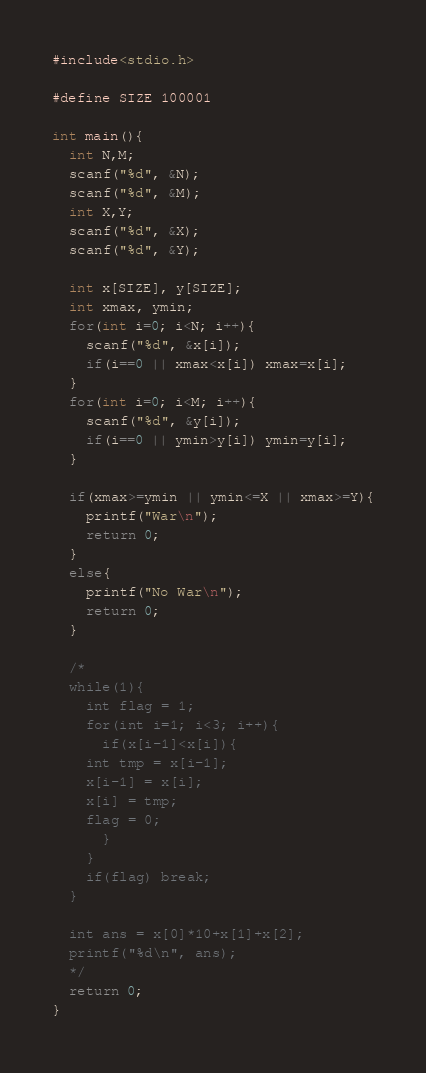Convert code to text. <code><loc_0><loc_0><loc_500><loc_500><_C_>#include<stdio.h>

#define SIZE 100001

int main(){
  int N,M;
  scanf("%d", &N);
  scanf("%d", &M);
  int X,Y;
  scanf("%d", &X);
  scanf("%d", &Y);

  int x[SIZE], y[SIZE];
  int xmax, ymin;
  for(int i=0; i<N; i++){
    scanf("%d", &x[i]);
    if(i==0 || xmax<x[i]) xmax=x[i];
  }
  for(int i=0; i<M; i++){
    scanf("%d", &y[i]);   
    if(i==0 || ymin>y[i]) ymin=y[i];
  }

  if(xmax>=ymin || ymin<=X || xmax>=Y){
    printf("War\n");
    return 0;
  }
  else{
    printf("No War\n");
    return 0;
  }

  /*
  while(1){
    int flag = 1;
    for(int i=1; i<3; i++){
      if(x[i-1]<x[i]){
	int tmp = x[i-1];
	x[i-1] = x[i];
	x[i] = tmp;
	flag = 0;
      }
    }
    if(flag) break;
  }

  int ans = x[0]*10+x[1]+x[2];
  printf("%d\n", ans);
  */
  return 0;
}
</code> 